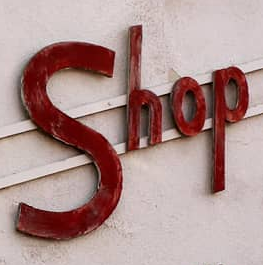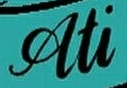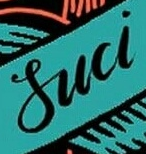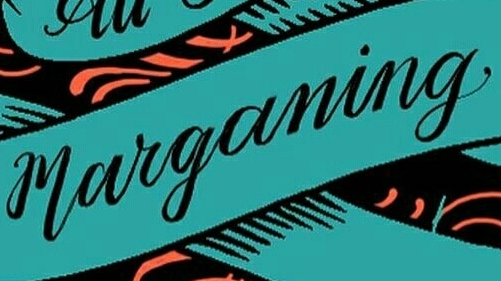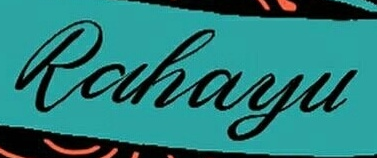Identify the words shown in these images in order, separated by a semicolon. Shop; Ati; Suci; marganing; Rahayu 